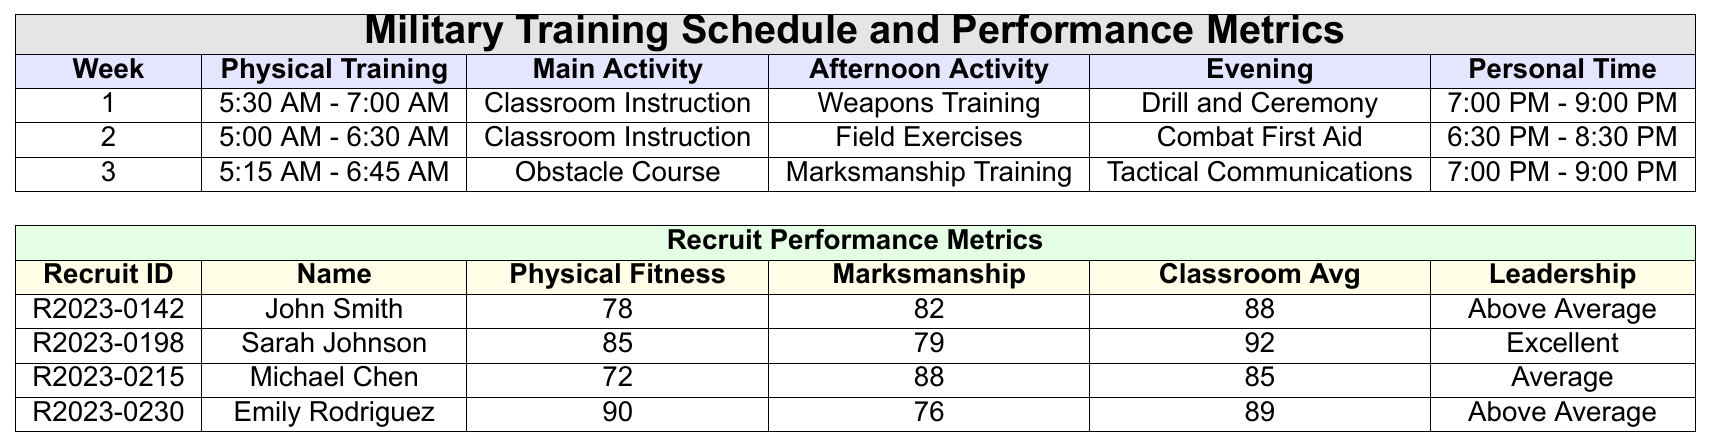What time does Physical Training start in Week 1? According to the table under Week 1, Physical Training starts at 5:30 AM.
Answer: 5:30 AM What is the Classroom Test Average of Sarah Johnson? The table indicates that Sarah Johnson has a Classroom Test Average of 92.
Answer: 92 Who has the lowest Physical Fitness Score among the recruits? By comparing the Physical Fitness Scores, Michael Chen has the lowest score of 72.
Answer: Michael Chen What are the different activities scheduled in Week 2? In Week 2, the activities are Physical Training from 5:00 AM - 6:30 AM, Classroom Instruction, Field Exercises, Combat First Aid, and Personal Time from 6:30 PM - 8:30 PM.
Answer: Physical Training, Classroom Instruction, Field Exercises, Combat First Aid, Personal Time How much lower is John Smith's Marksmanship Score compared to Emily Rodriguez's? John Smith has a Marksmanship Score of 82, while Emily Rodriguez scores 76. The difference is 82 - 76 = 6.
Answer: 6 What is the maximum Classroom Test Average among the recruits? The highest Classroom Test Average is 92, held by Sarah Johnson.
Answer: 92 Were there any recruits with Disciplinary Actions? Yes, John Smith and Michael Chen each have 1 and 2 Disciplinary Actions, respectively.
Answer: Yes Calculate the average Physical Fitness Score of the recruits. The Physical Fitness Scores are 78, 85, 72, and 90. The total is 78 + 85 + 72 + 90 = 325, and dividing by 4 gives an average of 325 / 4 = 81.25.
Answer: 81.25 Is Emily Rodriguez's Leadership Assessment "Excellent"? Emily Rodriguez has a Leadership Assessment listed as "Above Average," not "Excellent."
Answer: No Which recruit has the highest score in Marksmanship? Michael Chen has the highest Marksmanship Score of 88 compared to others in the table.
Answer: Michael Chen 